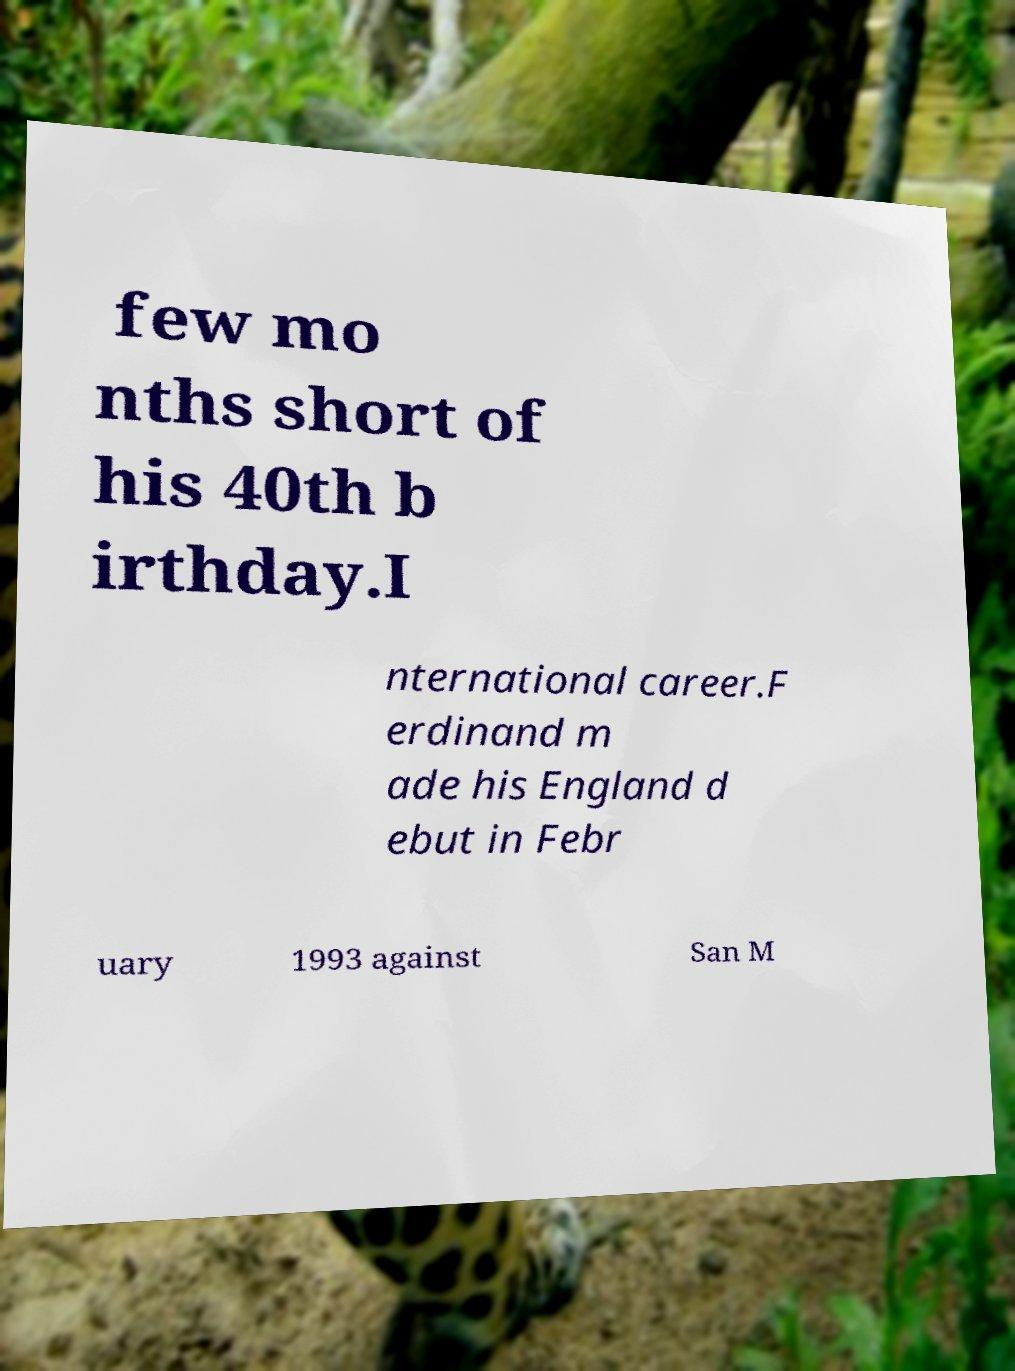Please identify and transcribe the text found in this image. few mo nths short of his 40th b irthday.I nternational career.F erdinand m ade his England d ebut in Febr uary 1993 against San M 